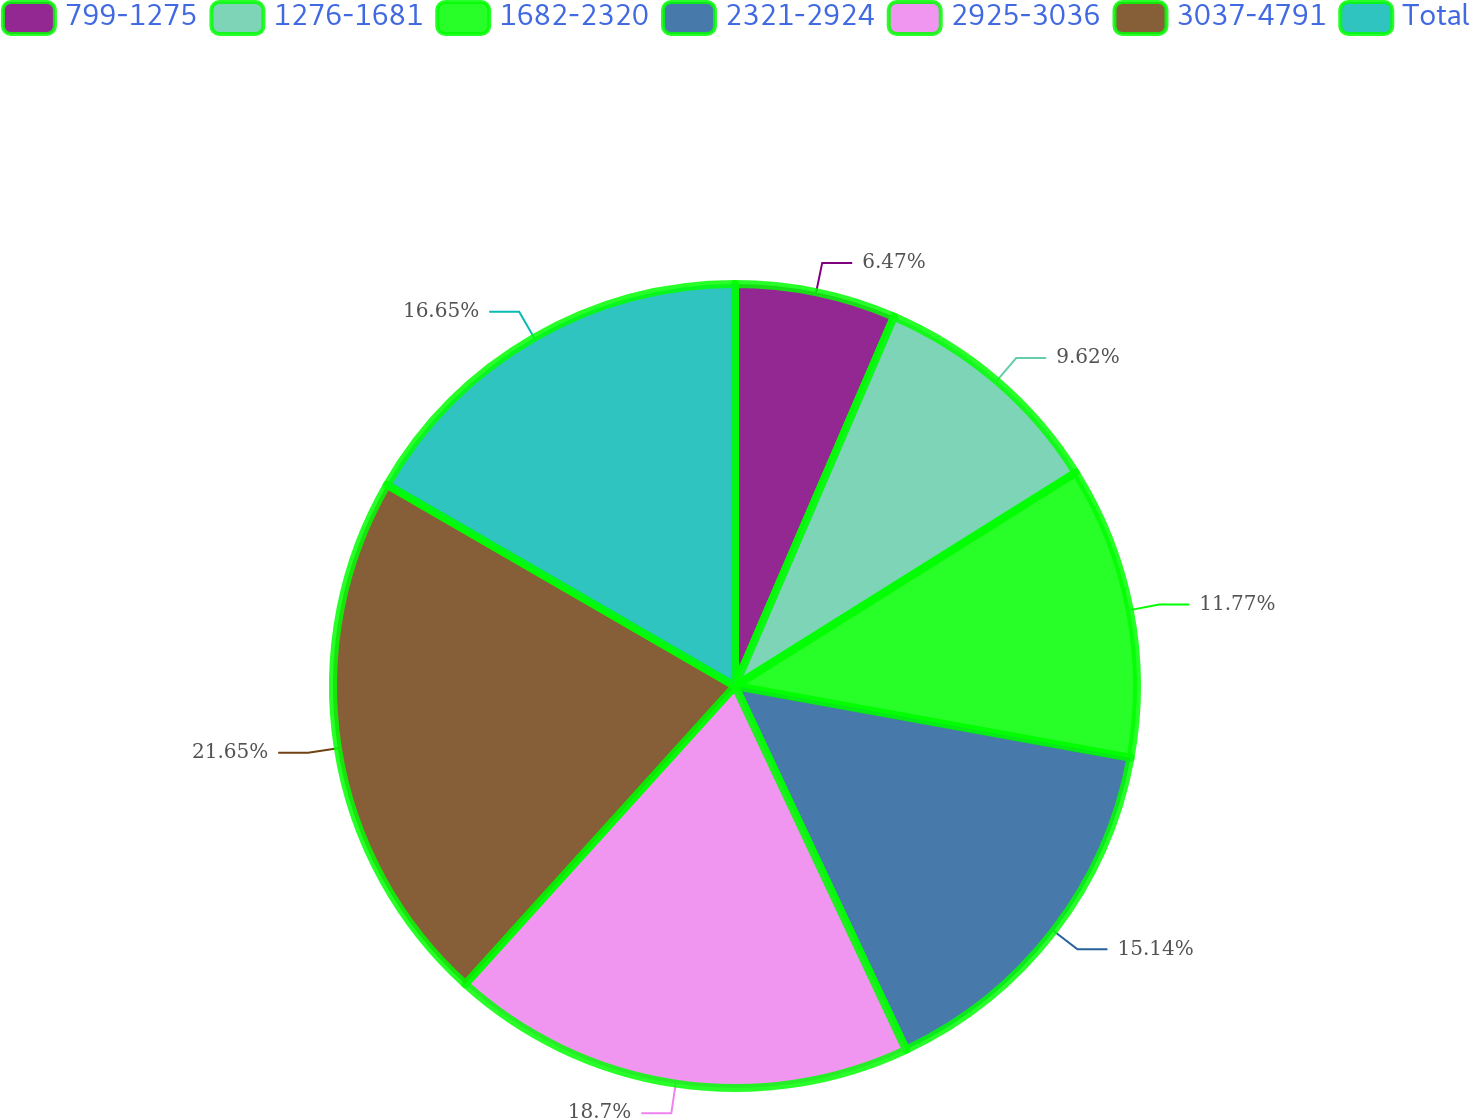Convert chart. <chart><loc_0><loc_0><loc_500><loc_500><pie_chart><fcel>799-1275<fcel>1276-1681<fcel>1682-2320<fcel>2321-2924<fcel>2925-3036<fcel>3037-4791<fcel>Total<nl><fcel>6.47%<fcel>9.62%<fcel>11.77%<fcel>15.14%<fcel>18.7%<fcel>21.64%<fcel>16.65%<nl></chart> 